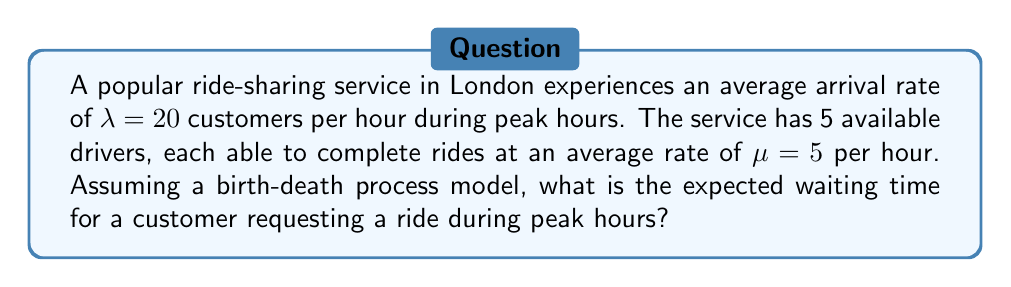Could you help me with this problem? To solve this problem, we'll use the M/M/c queueing model, where c is the number of servers (drivers in this case). Let's follow these steps:

1. Calculate the traffic intensity $\rho$:
   $$\rho = \frac{\lambda}{c\mu} = \frac{20}{5 \cdot 5} = 0.8$$

2. Calculate $P_0$, the probability of having no customers in the system:
   $$P_0 = \left[\sum_{n=0}^{c-1}\frac{(c\rho)^n}{n!} + \frac{(c\rho)^c}{c!(1-\rho)}\right]^{-1}$$
   
   Substituting the values:
   $$P_0 = \left[\sum_{n=0}^{4}\frac{(5 \cdot 0.8)^n}{n!} + \frac{(5 \cdot 0.8)^5}{5!(1-0.8)}\right]^{-1} \approx 0.0278$$

3. Calculate $L_q$, the expected number of customers in the queue:
   $$L_q = \frac{P_0(c\rho)^c\rho}{c!(1-\rho)^2} = \frac{0.0278 \cdot (5 \cdot 0.8)^5 \cdot 0.8}{5!(1-0.8)^2} \approx 2.7859$$

4. Calculate $W_q$, the expected waiting time in the queue:
   $$W_q = \frac{L_q}{\lambda} = \frac{2.7859}{20} \approx 0.1393\text{ hours}$$

5. Convert the waiting time to minutes:
   $$0.1393 \text{ hours} \cdot 60 \text{ minutes/hour} \approx 8.36 \text{ minutes}$$
Answer: 8.36 minutes 